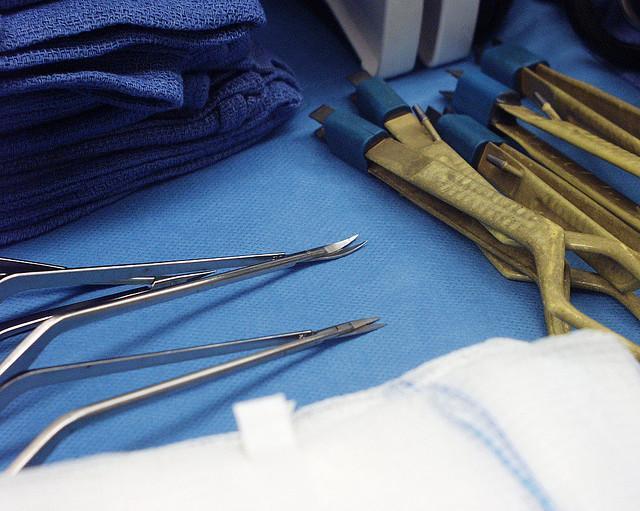How many scissors are there?
Give a very brief answer. 2. 